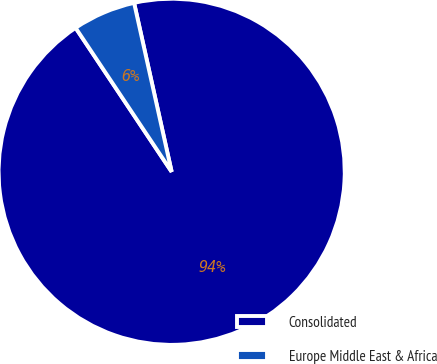Convert chart. <chart><loc_0><loc_0><loc_500><loc_500><pie_chart><fcel>Consolidated<fcel>Europe Middle East & Africa<nl><fcel>94.12%<fcel>5.88%<nl></chart> 